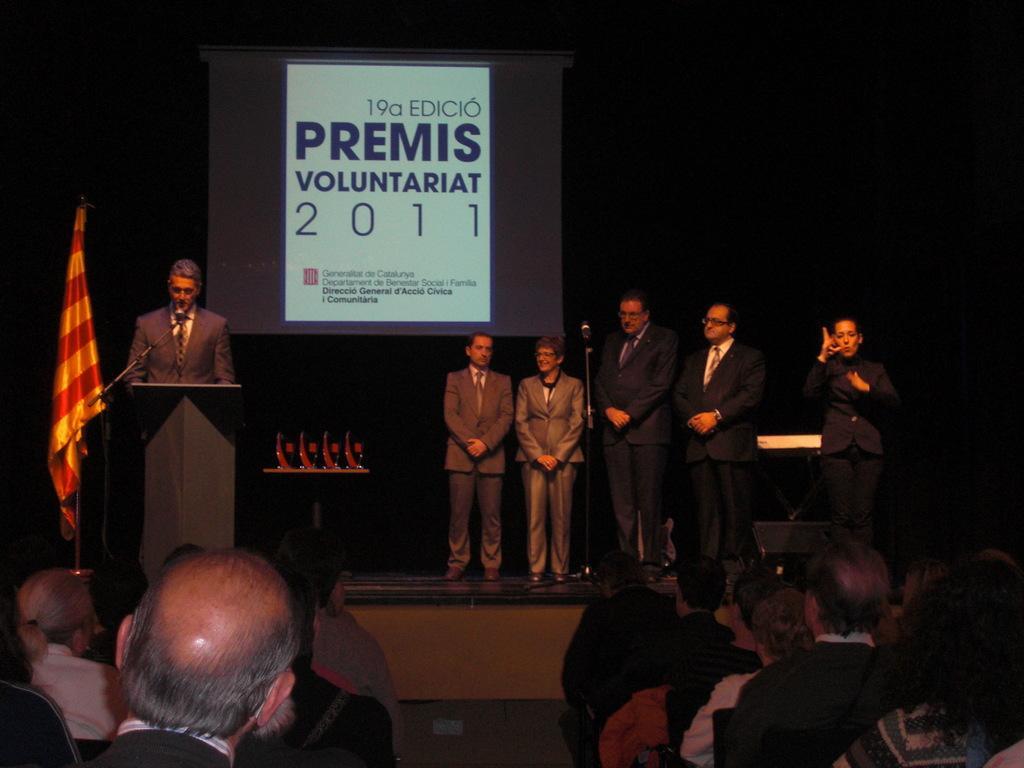In one or two sentences, can you explain what this image depicts? In this image there are people sitting on chairs, in front of there is a stage, on that stage there are people standing and there is a podium, flag, in the background there is a screen, on that screen there is some text. 